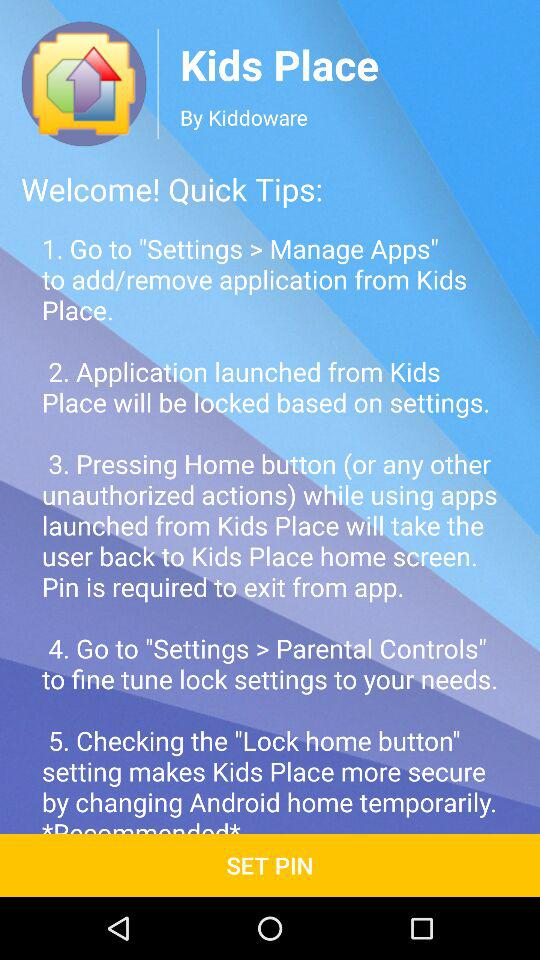How many quick tips are there?
Answer the question using a single word or phrase. 5 